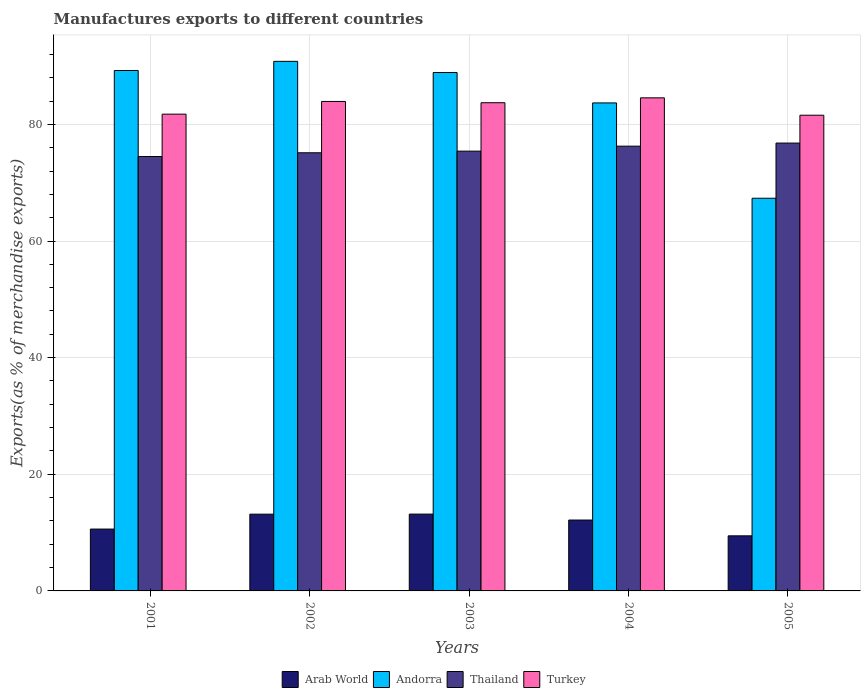How many groups of bars are there?
Keep it short and to the point. 5. Are the number of bars per tick equal to the number of legend labels?
Your answer should be compact. Yes. Are the number of bars on each tick of the X-axis equal?
Make the answer very short. Yes. How many bars are there on the 2nd tick from the left?
Your response must be concise. 4. What is the percentage of exports to different countries in Turkey in 2002?
Make the answer very short. 83.93. Across all years, what is the maximum percentage of exports to different countries in Turkey?
Offer a very short reply. 84.55. Across all years, what is the minimum percentage of exports to different countries in Turkey?
Your answer should be compact. 81.57. What is the total percentage of exports to different countries in Turkey in the graph?
Give a very brief answer. 415.52. What is the difference between the percentage of exports to different countries in Thailand in 2003 and that in 2005?
Give a very brief answer. -1.38. What is the difference between the percentage of exports to different countries in Thailand in 2003 and the percentage of exports to different countries in Andorra in 2001?
Make the answer very short. -13.83. What is the average percentage of exports to different countries in Andorra per year?
Give a very brief answer. 83.99. In the year 2005, what is the difference between the percentage of exports to different countries in Turkey and percentage of exports to different countries in Arab World?
Offer a terse response. 72.13. In how many years, is the percentage of exports to different countries in Andorra greater than 20 %?
Your answer should be compact. 5. What is the ratio of the percentage of exports to different countries in Turkey in 2001 to that in 2003?
Offer a terse response. 0.98. Is the percentage of exports to different countries in Turkey in 2004 less than that in 2005?
Provide a short and direct response. No. What is the difference between the highest and the second highest percentage of exports to different countries in Arab World?
Ensure brevity in your answer.  0.01. What is the difference between the highest and the lowest percentage of exports to different countries in Turkey?
Provide a succinct answer. 2.98. In how many years, is the percentage of exports to different countries in Thailand greater than the average percentage of exports to different countries in Thailand taken over all years?
Your answer should be very brief. 2. What does the 3rd bar from the left in 2005 represents?
Offer a terse response. Thailand. What does the 1st bar from the right in 2005 represents?
Your response must be concise. Turkey. Is it the case that in every year, the sum of the percentage of exports to different countries in Arab World and percentage of exports to different countries in Turkey is greater than the percentage of exports to different countries in Andorra?
Your answer should be very brief. Yes. How many bars are there?
Make the answer very short. 20. Are all the bars in the graph horizontal?
Make the answer very short. No. What is the difference between two consecutive major ticks on the Y-axis?
Offer a very short reply. 20. Does the graph contain grids?
Your answer should be very brief. Yes. How are the legend labels stacked?
Provide a short and direct response. Horizontal. What is the title of the graph?
Make the answer very short. Manufactures exports to different countries. Does "Heavily indebted poor countries" appear as one of the legend labels in the graph?
Provide a short and direct response. No. What is the label or title of the Y-axis?
Make the answer very short. Exports(as % of merchandise exports). What is the Exports(as % of merchandise exports) in Arab World in 2001?
Your response must be concise. 10.61. What is the Exports(as % of merchandise exports) in Andorra in 2001?
Offer a very short reply. 89.24. What is the Exports(as % of merchandise exports) in Thailand in 2001?
Your answer should be compact. 74.49. What is the Exports(as % of merchandise exports) in Turkey in 2001?
Provide a short and direct response. 81.75. What is the Exports(as % of merchandise exports) of Arab World in 2002?
Offer a very short reply. 13.16. What is the Exports(as % of merchandise exports) in Andorra in 2002?
Your answer should be compact. 90.81. What is the Exports(as % of merchandise exports) of Thailand in 2002?
Provide a short and direct response. 75.13. What is the Exports(as % of merchandise exports) in Turkey in 2002?
Give a very brief answer. 83.93. What is the Exports(as % of merchandise exports) in Arab World in 2003?
Give a very brief answer. 13.17. What is the Exports(as % of merchandise exports) of Andorra in 2003?
Give a very brief answer. 88.89. What is the Exports(as % of merchandise exports) of Thailand in 2003?
Keep it short and to the point. 75.41. What is the Exports(as % of merchandise exports) in Turkey in 2003?
Offer a very short reply. 83.71. What is the Exports(as % of merchandise exports) of Arab World in 2004?
Offer a very short reply. 12.15. What is the Exports(as % of merchandise exports) of Andorra in 2004?
Provide a short and direct response. 83.68. What is the Exports(as % of merchandise exports) of Thailand in 2004?
Your answer should be very brief. 76.26. What is the Exports(as % of merchandise exports) of Turkey in 2004?
Offer a very short reply. 84.55. What is the Exports(as % of merchandise exports) in Arab World in 2005?
Ensure brevity in your answer.  9.45. What is the Exports(as % of merchandise exports) in Andorra in 2005?
Keep it short and to the point. 67.34. What is the Exports(as % of merchandise exports) of Thailand in 2005?
Offer a very short reply. 76.8. What is the Exports(as % of merchandise exports) of Turkey in 2005?
Provide a short and direct response. 81.57. Across all years, what is the maximum Exports(as % of merchandise exports) of Arab World?
Give a very brief answer. 13.17. Across all years, what is the maximum Exports(as % of merchandise exports) in Andorra?
Your answer should be compact. 90.81. Across all years, what is the maximum Exports(as % of merchandise exports) in Thailand?
Offer a terse response. 76.8. Across all years, what is the maximum Exports(as % of merchandise exports) in Turkey?
Offer a very short reply. 84.55. Across all years, what is the minimum Exports(as % of merchandise exports) of Arab World?
Your answer should be compact. 9.45. Across all years, what is the minimum Exports(as % of merchandise exports) of Andorra?
Offer a terse response. 67.34. Across all years, what is the minimum Exports(as % of merchandise exports) of Thailand?
Offer a very short reply. 74.49. Across all years, what is the minimum Exports(as % of merchandise exports) of Turkey?
Keep it short and to the point. 81.57. What is the total Exports(as % of merchandise exports) in Arab World in the graph?
Your answer should be compact. 58.54. What is the total Exports(as % of merchandise exports) of Andorra in the graph?
Make the answer very short. 419.95. What is the total Exports(as % of merchandise exports) of Thailand in the graph?
Your answer should be very brief. 378.09. What is the total Exports(as % of merchandise exports) in Turkey in the graph?
Make the answer very short. 415.52. What is the difference between the Exports(as % of merchandise exports) of Arab World in 2001 and that in 2002?
Give a very brief answer. -2.56. What is the difference between the Exports(as % of merchandise exports) of Andorra in 2001 and that in 2002?
Make the answer very short. -1.57. What is the difference between the Exports(as % of merchandise exports) in Thailand in 2001 and that in 2002?
Ensure brevity in your answer.  -0.64. What is the difference between the Exports(as % of merchandise exports) in Turkey in 2001 and that in 2002?
Ensure brevity in your answer.  -2.18. What is the difference between the Exports(as % of merchandise exports) of Arab World in 2001 and that in 2003?
Offer a very short reply. -2.56. What is the difference between the Exports(as % of merchandise exports) of Andorra in 2001 and that in 2003?
Ensure brevity in your answer.  0.35. What is the difference between the Exports(as % of merchandise exports) in Thailand in 2001 and that in 2003?
Ensure brevity in your answer.  -0.92. What is the difference between the Exports(as % of merchandise exports) in Turkey in 2001 and that in 2003?
Ensure brevity in your answer.  -1.96. What is the difference between the Exports(as % of merchandise exports) of Arab World in 2001 and that in 2004?
Provide a short and direct response. -1.55. What is the difference between the Exports(as % of merchandise exports) in Andorra in 2001 and that in 2004?
Your answer should be very brief. 5.56. What is the difference between the Exports(as % of merchandise exports) in Thailand in 2001 and that in 2004?
Your response must be concise. -1.78. What is the difference between the Exports(as % of merchandise exports) of Turkey in 2001 and that in 2004?
Ensure brevity in your answer.  -2.8. What is the difference between the Exports(as % of merchandise exports) of Arab World in 2001 and that in 2005?
Ensure brevity in your answer.  1.16. What is the difference between the Exports(as % of merchandise exports) of Andorra in 2001 and that in 2005?
Ensure brevity in your answer.  21.9. What is the difference between the Exports(as % of merchandise exports) of Thailand in 2001 and that in 2005?
Ensure brevity in your answer.  -2.31. What is the difference between the Exports(as % of merchandise exports) in Turkey in 2001 and that in 2005?
Provide a short and direct response. 0.18. What is the difference between the Exports(as % of merchandise exports) of Arab World in 2002 and that in 2003?
Provide a short and direct response. -0.01. What is the difference between the Exports(as % of merchandise exports) of Andorra in 2002 and that in 2003?
Give a very brief answer. 1.91. What is the difference between the Exports(as % of merchandise exports) of Thailand in 2002 and that in 2003?
Offer a terse response. -0.28. What is the difference between the Exports(as % of merchandise exports) in Turkey in 2002 and that in 2003?
Provide a succinct answer. 0.22. What is the difference between the Exports(as % of merchandise exports) of Andorra in 2002 and that in 2004?
Ensure brevity in your answer.  7.13. What is the difference between the Exports(as % of merchandise exports) of Thailand in 2002 and that in 2004?
Make the answer very short. -1.13. What is the difference between the Exports(as % of merchandise exports) of Turkey in 2002 and that in 2004?
Offer a terse response. -0.62. What is the difference between the Exports(as % of merchandise exports) of Arab World in 2002 and that in 2005?
Your answer should be very brief. 3.72. What is the difference between the Exports(as % of merchandise exports) in Andorra in 2002 and that in 2005?
Keep it short and to the point. 23.47. What is the difference between the Exports(as % of merchandise exports) in Thailand in 2002 and that in 2005?
Offer a very short reply. -1.67. What is the difference between the Exports(as % of merchandise exports) in Turkey in 2002 and that in 2005?
Your response must be concise. 2.36. What is the difference between the Exports(as % of merchandise exports) of Arab World in 2003 and that in 2004?
Provide a succinct answer. 1.02. What is the difference between the Exports(as % of merchandise exports) of Andorra in 2003 and that in 2004?
Your answer should be very brief. 5.21. What is the difference between the Exports(as % of merchandise exports) in Thailand in 2003 and that in 2004?
Your answer should be very brief. -0.85. What is the difference between the Exports(as % of merchandise exports) in Turkey in 2003 and that in 2004?
Offer a terse response. -0.84. What is the difference between the Exports(as % of merchandise exports) in Arab World in 2003 and that in 2005?
Provide a succinct answer. 3.72. What is the difference between the Exports(as % of merchandise exports) in Andorra in 2003 and that in 2005?
Your answer should be very brief. 21.56. What is the difference between the Exports(as % of merchandise exports) of Thailand in 2003 and that in 2005?
Make the answer very short. -1.38. What is the difference between the Exports(as % of merchandise exports) of Turkey in 2003 and that in 2005?
Make the answer very short. 2.14. What is the difference between the Exports(as % of merchandise exports) of Arab World in 2004 and that in 2005?
Give a very brief answer. 2.71. What is the difference between the Exports(as % of merchandise exports) in Andorra in 2004 and that in 2005?
Your response must be concise. 16.34. What is the difference between the Exports(as % of merchandise exports) of Thailand in 2004 and that in 2005?
Offer a very short reply. -0.53. What is the difference between the Exports(as % of merchandise exports) in Turkey in 2004 and that in 2005?
Your response must be concise. 2.98. What is the difference between the Exports(as % of merchandise exports) of Arab World in 2001 and the Exports(as % of merchandise exports) of Andorra in 2002?
Your response must be concise. -80.2. What is the difference between the Exports(as % of merchandise exports) in Arab World in 2001 and the Exports(as % of merchandise exports) in Thailand in 2002?
Offer a terse response. -64.52. What is the difference between the Exports(as % of merchandise exports) in Arab World in 2001 and the Exports(as % of merchandise exports) in Turkey in 2002?
Provide a succinct answer. -73.33. What is the difference between the Exports(as % of merchandise exports) in Andorra in 2001 and the Exports(as % of merchandise exports) in Thailand in 2002?
Your answer should be very brief. 14.11. What is the difference between the Exports(as % of merchandise exports) of Andorra in 2001 and the Exports(as % of merchandise exports) of Turkey in 2002?
Offer a very short reply. 5.31. What is the difference between the Exports(as % of merchandise exports) of Thailand in 2001 and the Exports(as % of merchandise exports) of Turkey in 2002?
Give a very brief answer. -9.45. What is the difference between the Exports(as % of merchandise exports) of Arab World in 2001 and the Exports(as % of merchandise exports) of Andorra in 2003?
Ensure brevity in your answer.  -78.29. What is the difference between the Exports(as % of merchandise exports) of Arab World in 2001 and the Exports(as % of merchandise exports) of Thailand in 2003?
Offer a terse response. -64.8. What is the difference between the Exports(as % of merchandise exports) in Arab World in 2001 and the Exports(as % of merchandise exports) in Turkey in 2003?
Keep it short and to the point. -73.11. What is the difference between the Exports(as % of merchandise exports) of Andorra in 2001 and the Exports(as % of merchandise exports) of Thailand in 2003?
Keep it short and to the point. 13.83. What is the difference between the Exports(as % of merchandise exports) in Andorra in 2001 and the Exports(as % of merchandise exports) in Turkey in 2003?
Your answer should be compact. 5.53. What is the difference between the Exports(as % of merchandise exports) in Thailand in 2001 and the Exports(as % of merchandise exports) in Turkey in 2003?
Make the answer very short. -9.23. What is the difference between the Exports(as % of merchandise exports) in Arab World in 2001 and the Exports(as % of merchandise exports) in Andorra in 2004?
Offer a terse response. -73.07. What is the difference between the Exports(as % of merchandise exports) of Arab World in 2001 and the Exports(as % of merchandise exports) of Thailand in 2004?
Ensure brevity in your answer.  -65.66. What is the difference between the Exports(as % of merchandise exports) in Arab World in 2001 and the Exports(as % of merchandise exports) in Turkey in 2004?
Provide a succinct answer. -73.94. What is the difference between the Exports(as % of merchandise exports) in Andorra in 2001 and the Exports(as % of merchandise exports) in Thailand in 2004?
Offer a terse response. 12.98. What is the difference between the Exports(as % of merchandise exports) in Andorra in 2001 and the Exports(as % of merchandise exports) in Turkey in 2004?
Keep it short and to the point. 4.69. What is the difference between the Exports(as % of merchandise exports) in Thailand in 2001 and the Exports(as % of merchandise exports) in Turkey in 2004?
Ensure brevity in your answer.  -10.06. What is the difference between the Exports(as % of merchandise exports) of Arab World in 2001 and the Exports(as % of merchandise exports) of Andorra in 2005?
Keep it short and to the point. -56.73. What is the difference between the Exports(as % of merchandise exports) of Arab World in 2001 and the Exports(as % of merchandise exports) of Thailand in 2005?
Offer a terse response. -66.19. What is the difference between the Exports(as % of merchandise exports) of Arab World in 2001 and the Exports(as % of merchandise exports) of Turkey in 2005?
Ensure brevity in your answer.  -70.97. What is the difference between the Exports(as % of merchandise exports) in Andorra in 2001 and the Exports(as % of merchandise exports) in Thailand in 2005?
Offer a terse response. 12.44. What is the difference between the Exports(as % of merchandise exports) in Andorra in 2001 and the Exports(as % of merchandise exports) in Turkey in 2005?
Ensure brevity in your answer.  7.67. What is the difference between the Exports(as % of merchandise exports) in Thailand in 2001 and the Exports(as % of merchandise exports) in Turkey in 2005?
Offer a terse response. -7.09. What is the difference between the Exports(as % of merchandise exports) of Arab World in 2002 and the Exports(as % of merchandise exports) of Andorra in 2003?
Provide a succinct answer. -75.73. What is the difference between the Exports(as % of merchandise exports) of Arab World in 2002 and the Exports(as % of merchandise exports) of Thailand in 2003?
Provide a succinct answer. -62.25. What is the difference between the Exports(as % of merchandise exports) of Arab World in 2002 and the Exports(as % of merchandise exports) of Turkey in 2003?
Your response must be concise. -70.55. What is the difference between the Exports(as % of merchandise exports) in Andorra in 2002 and the Exports(as % of merchandise exports) in Thailand in 2003?
Offer a very short reply. 15.4. What is the difference between the Exports(as % of merchandise exports) of Andorra in 2002 and the Exports(as % of merchandise exports) of Turkey in 2003?
Your answer should be compact. 7.09. What is the difference between the Exports(as % of merchandise exports) in Thailand in 2002 and the Exports(as % of merchandise exports) in Turkey in 2003?
Provide a short and direct response. -8.58. What is the difference between the Exports(as % of merchandise exports) in Arab World in 2002 and the Exports(as % of merchandise exports) in Andorra in 2004?
Your answer should be compact. -70.52. What is the difference between the Exports(as % of merchandise exports) of Arab World in 2002 and the Exports(as % of merchandise exports) of Thailand in 2004?
Keep it short and to the point. -63.1. What is the difference between the Exports(as % of merchandise exports) of Arab World in 2002 and the Exports(as % of merchandise exports) of Turkey in 2004?
Offer a very short reply. -71.39. What is the difference between the Exports(as % of merchandise exports) of Andorra in 2002 and the Exports(as % of merchandise exports) of Thailand in 2004?
Your answer should be very brief. 14.54. What is the difference between the Exports(as % of merchandise exports) in Andorra in 2002 and the Exports(as % of merchandise exports) in Turkey in 2004?
Offer a terse response. 6.26. What is the difference between the Exports(as % of merchandise exports) in Thailand in 2002 and the Exports(as % of merchandise exports) in Turkey in 2004?
Give a very brief answer. -9.42. What is the difference between the Exports(as % of merchandise exports) of Arab World in 2002 and the Exports(as % of merchandise exports) of Andorra in 2005?
Ensure brevity in your answer.  -54.17. What is the difference between the Exports(as % of merchandise exports) in Arab World in 2002 and the Exports(as % of merchandise exports) in Thailand in 2005?
Your answer should be very brief. -63.63. What is the difference between the Exports(as % of merchandise exports) in Arab World in 2002 and the Exports(as % of merchandise exports) in Turkey in 2005?
Make the answer very short. -68.41. What is the difference between the Exports(as % of merchandise exports) in Andorra in 2002 and the Exports(as % of merchandise exports) in Thailand in 2005?
Ensure brevity in your answer.  14.01. What is the difference between the Exports(as % of merchandise exports) in Andorra in 2002 and the Exports(as % of merchandise exports) in Turkey in 2005?
Provide a succinct answer. 9.23. What is the difference between the Exports(as % of merchandise exports) of Thailand in 2002 and the Exports(as % of merchandise exports) of Turkey in 2005?
Your answer should be very brief. -6.44. What is the difference between the Exports(as % of merchandise exports) of Arab World in 2003 and the Exports(as % of merchandise exports) of Andorra in 2004?
Give a very brief answer. -70.51. What is the difference between the Exports(as % of merchandise exports) of Arab World in 2003 and the Exports(as % of merchandise exports) of Thailand in 2004?
Keep it short and to the point. -63.09. What is the difference between the Exports(as % of merchandise exports) in Arab World in 2003 and the Exports(as % of merchandise exports) in Turkey in 2004?
Your response must be concise. -71.38. What is the difference between the Exports(as % of merchandise exports) of Andorra in 2003 and the Exports(as % of merchandise exports) of Thailand in 2004?
Provide a short and direct response. 12.63. What is the difference between the Exports(as % of merchandise exports) in Andorra in 2003 and the Exports(as % of merchandise exports) in Turkey in 2004?
Make the answer very short. 4.34. What is the difference between the Exports(as % of merchandise exports) in Thailand in 2003 and the Exports(as % of merchandise exports) in Turkey in 2004?
Keep it short and to the point. -9.14. What is the difference between the Exports(as % of merchandise exports) of Arab World in 2003 and the Exports(as % of merchandise exports) of Andorra in 2005?
Your answer should be very brief. -54.16. What is the difference between the Exports(as % of merchandise exports) of Arab World in 2003 and the Exports(as % of merchandise exports) of Thailand in 2005?
Offer a terse response. -63.62. What is the difference between the Exports(as % of merchandise exports) of Arab World in 2003 and the Exports(as % of merchandise exports) of Turkey in 2005?
Make the answer very short. -68.4. What is the difference between the Exports(as % of merchandise exports) in Andorra in 2003 and the Exports(as % of merchandise exports) in Thailand in 2005?
Your answer should be very brief. 12.1. What is the difference between the Exports(as % of merchandise exports) in Andorra in 2003 and the Exports(as % of merchandise exports) in Turkey in 2005?
Ensure brevity in your answer.  7.32. What is the difference between the Exports(as % of merchandise exports) in Thailand in 2003 and the Exports(as % of merchandise exports) in Turkey in 2005?
Your answer should be compact. -6.16. What is the difference between the Exports(as % of merchandise exports) of Arab World in 2004 and the Exports(as % of merchandise exports) of Andorra in 2005?
Your answer should be compact. -55.18. What is the difference between the Exports(as % of merchandise exports) of Arab World in 2004 and the Exports(as % of merchandise exports) of Thailand in 2005?
Ensure brevity in your answer.  -64.64. What is the difference between the Exports(as % of merchandise exports) in Arab World in 2004 and the Exports(as % of merchandise exports) in Turkey in 2005?
Offer a terse response. -69.42. What is the difference between the Exports(as % of merchandise exports) in Andorra in 2004 and the Exports(as % of merchandise exports) in Thailand in 2005?
Make the answer very short. 6.88. What is the difference between the Exports(as % of merchandise exports) in Andorra in 2004 and the Exports(as % of merchandise exports) in Turkey in 2005?
Your answer should be very brief. 2.11. What is the difference between the Exports(as % of merchandise exports) in Thailand in 2004 and the Exports(as % of merchandise exports) in Turkey in 2005?
Give a very brief answer. -5.31. What is the average Exports(as % of merchandise exports) in Arab World per year?
Make the answer very short. 11.71. What is the average Exports(as % of merchandise exports) of Andorra per year?
Your answer should be compact. 83.99. What is the average Exports(as % of merchandise exports) of Thailand per year?
Keep it short and to the point. 75.62. What is the average Exports(as % of merchandise exports) of Turkey per year?
Your response must be concise. 83.1. In the year 2001, what is the difference between the Exports(as % of merchandise exports) of Arab World and Exports(as % of merchandise exports) of Andorra?
Your answer should be compact. -78.63. In the year 2001, what is the difference between the Exports(as % of merchandise exports) in Arab World and Exports(as % of merchandise exports) in Thailand?
Give a very brief answer. -63.88. In the year 2001, what is the difference between the Exports(as % of merchandise exports) in Arab World and Exports(as % of merchandise exports) in Turkey?
Your answer should be compact. -71.15. In the year 2001, what is the difference between the Exports(as % of merchandise exports) in Andorra and Exports(as % of merchandise exports) in Thailand?
Provide a succinct answer. 14.75. In the year 2001, what is the difference between the Exports(as % of merchandise exports) of Andorra and Exports(as % of merchandise exports) of Turkey?
Provide a succinct answer. 7.49. In the year 2001, what is the difference between the Exports(as % of merchandise exports) of Thailand and Exports(as % of merchandise exports) of Turkey?
Keep it short and to the point. -7.27. In the year 2002, what is the difference between the Exports(as % of merchandise exports) in Arab World and Exports(as % of merchandise exports) in Andorra?
Make the answer very short. -77.64. In the year 2002, what is the difference between the Exports(as % of merchandise exports) in Arab World and Exports(as % of merchandise exports) in Thailand?
Keep it short and to the point. -61.97. In the year 2002, what is the difference between the Exports(as % of merchandise exports) in Arab World and Exports(as % of merchandise exports) in Turkey?
Provide a short and direct response. -70.77. In the year 2002, what is the difference between the Exports(as % of merchandise exports) of Andorra and Exports(as % of merchandise exports) of Thailand?
Give a very brief answer. 15.68. In the year 2002, what is the difference between the Exports(as % of merchandise exports) of Andorra and Exports(as % of merchandise exports) of Turkey?
Offer a terse response. 6.87. In the year 2002, what is the difference between the Exports(as % of merchandise exports) in Thailand and Exports(as % of merchandise exports) in Turkey?
Provide a short and direct response. -8.8. In the year 2003, what is the difference between the Exports(as % of merchandise exports) of Arab World and Exports(as % of merchandise exports) of Andorra?
Ensure brevity in your answer.  -75.72. In the year 2003, what is the difference between the Exports(as % of merchandise exports) in Arab World and Exports(as % of merchandise exports) in Thailand?
Give a very brief answer. -62.24. In the year 2003, what is the difference between the Exports(as % of merchandise exports) of Arab World and Exports(as % of merchandise exports) of Turkey?
Keep it short and to the point. -70.54. In the year 2003, what is the difference between the Exports(as % of merchandise exports) in Andorra and Exports(as % of merchandise exports) in Thailand?
Give a very brief answer. 13.48. In the year 2003, what is the difference between the Exports(as % of merchandise exports) in Andorra and Exports(as % of merchandise exports) in Turkey?
Your response must be concise. 5.18. In the year 2003, what is the difference between the Exports(as % of merchandise exports) in Thailand and Exports(as % of merchandise exports) in Turkey?
Offer a terse response. -8.3. In the year 2004, what is the difference between the Exports(as % of merchandise exports) in Arab World and Exports(as % of merchandise exports) in Andorra?
Provide a short and direct response. -71.53. In the year 2004, what is the difference between the Exports(as % of merchandise exports) in Arab World and Exports(as % of merchandise exports) in Thailand?
Provide a short and direct response. -64.11. In the year 2004, what is the difference between the Exports(as % of merchandise exports) of Arab World and Exports(as % of merchandise exports) of Turkey?
Provide a short and direct response. -72.4. In the year 2004, what is the difference between the Exports(as % of merchandise exports) of Andorra and Exports(as % of merchandise exports) of Thailand?
Provide a short and direct response. 7.42. In the year 2004, what is the difference between the Exports(as % of merchandise exports) in Andorra and Exports(as % of merchandise exports) in Turkey?
Your answer should be very brief. -0.87. In the year 2004, what is the difference between the Exports(as % of merchandise exports) in Thailand and Exports(as % of merchandise exports) in Turkey?
Your answer should be very brief. -8.29. In the year 2005, what is the difference between the Exports(as % of merchandise exports) of Arab World and Exports(as % of merchandise exports) of Andorra?
Make the answer very short. -57.89. In the year 2005, what is the difference between the Exports(as % of merchandise exports) of Arab World and Exports(as % of merchandise exports) of Thailand?
Keep it short and to the point. -67.35. In the year 2005, what is the difference between the Exports(as % of merchandise exports) of Arab World and Exports(as % of merchandise exports) of Turkey?
Your answer should be very brief. -72.13. In the year 2005, what is the difference between the Exports(as % of merchandise exports) in Andorra and Exports(as % of merchandise exports) in Thailand?
Keep it short and to the point. -9.46. In the year 2005, what is the difference between the Exports(as % of merchandise exports) in Andorra and Exports(as % of merchandise exports) in Turkey?
Your response must be concise. -14.24. In the year 2005, what is the difference between the Exports(as % of merchandise exports) in Thailand and Exports(as % of merchandise exports) in Turkey?
Offer a very short reply. -4.78. What is the ratio of the Exports(as % of merchandise exports) in Arab World in 2001 to that in 2002?
Provide a short and direct response. 0.81. What is the ratio of the Exports(as % of merchandise exports) in Andorra in 2001 to that in 2002?
Offer a terse response. 0.98. What is the ratio of the Exports(as % of merchandise exports) of Turkey in 2001 to that in 2002?
Your response must be concise. 0.97. What is the ratio of the Exports(as % of merchandise exports) in Arab World in 2001 to that in 2003?
Provide a short and direct response. 0.81. What is the ratio of the Exports(as % of merchandise exports) in Andorra in 2001 to that in 2003?
Your answer should be compact. 1. What is the ratio of the Exports(as % of merchandise exports) in Turkey in 2001 to that in 2003?
Give a very brief answer. 0.98. What is the ratio of the Exports(as % of merchandise exports) of Arab World in 2001 to that in 2004?
Ensure brevity in your answer.  0.87. What is the ratio of the Exports(as % of merchandise exports) in Andorra in 2001 to that in 2004?
Your answer should be compact. 1.07. What is the ratio of the Exports(as % of merchandise exports) of Thailand in 2001 to that in 2004?
Provide a succinct answer. 0.98. What is the ratio of the Exports(as % of merchandise exports) of Turkey in 2001 to that in 2004?
Keep it short and to the point. 0.97. What is the ratio of the Exports(as % of merchandise exports) in Arab World in 2001 to that in 2005?
Keep it short and to the point. 1.12. What is the ratio of the Exports(as % of merchandise exports) of Andorra in 2001 to that in 2005?
Keep it short and to the point. 1.33. What is the ratio of the Exports(as % of merchandise exports) in Thailand in 2001 to that in 2005?
Provide a short and direct response. 0.97. What is the ratio of the Exports(as % of merchandise exports) in Turkey in 2001 to that in 2005?
Your answer should be very brief. 1. What is the ratio of the Exports(as % of merchandise exports) in Andorra in 2002 to that in 2003?
Your answer should be compact. 1.02. What is the ratio of the Exports(as % of merchandise exports) in Turkey in 2002 to that in 2003?
Make the answer very short. 1. What is the ratio of the Exports(as % of merchandise exports) in Arab World in 2002 to that in 2004?
Make the answer very short. 1.08. What is the ratio of the Exports(as % of merchandise exports) of Andorra in 2002 to that in 2004?
Your response must be concise. 1.09. What is the ratio of the Exports(as % of merchandise exports) in Thailand in 2002 to that in 2004?
Give a very brief answer. 0.99. What is the ratio of the Exports(as % of merchandise exports) in Turkey in 2002 to that in 2004?
Give a very brief answer. 0.99. What is the ratio of the Exports(as % of merchandise exports) of Arab World in 2002 to that in 2005?
Provide a succinct answer. 1.39. What is the ratio of the Exports(as % of merchandise exports) in Andorra in 2002 to that in 2005?
Your answer should be very brief. 1.35. What is the ratio of the Exports(as % of merchandise exports) of Thailand in 2002 to that in 2005?
Ensure brevity in your answer.  0.98. What is the ratio of the Exports(as % of merchandise exports) of Turkey in 2002 to that in 2005?
Give a very brief answer. 1.03. What is the ratio of the Exports(as % of merchandise exports) of Arab World in 2003 to that in 2004?
Make the answer very short. 1.08. What is the ratio of the Exports(as % of merchandise exports) of Andorra in 2003 to that in 2004?
Make the answer very short. 1.06. What is the ratio of the Exports(as % of merchandise exports) in Thailand in 2003 to that in 2004?
Your response must be concise. 0.99. What is the ratio of the Exports(as % of merchandise exports) of Arab World in 2003 to that in 2005?
Offer a very short reply. 1.39. What is the ratio of the Exports(as % of merchandise exports) in Andorra in 2003 to that in 2005?
Give a very brief answer. 1.32. What is the ratio of the Exports(as % of merchandise exports) of Thailand in 2003 to that in 2005?
Your answer should be compact. 0.98. What is the ratio of the Exports(as % of merchandise exports) in Turkey in 2003 to that in 2005?
Make the answer very short. 1.03. What is the ratio of the Exports(as % of merchandise exports) in Arab World in 2004 to that in 2005?
Give a very brief answer. 1.29. What is the ratio of the Exports(as % of merchandise exports) in Andorra in 2004 to that in 2005?
Provide a succinct answer. 1.24. What is the ratio of the Exports(as % of merchandise exports) of Turkey in 2004 to that in 2005?
Give a very brief answer. 1.04. What is the difference between the highest and the second highest Exports(as % of merchandise exports) in Arab World?
Offer a very short reply. 0.01. What is the difference between the highest and the second highest Exports(as % of merchandise exports) in Andorra?
Your answer should be compact. 1.57. What is the difference between the highest and the second highest Exports(as % of merchandise exports) of Thailand?
Give a very brief answer. 0.53. What is the difference between the highest and the second highest Exports(as % of merchandise exports) of Turkey?
Your response must be concise. 0.62. What is the difference between the highest and the lowest Exports(as % of merchandise exports) in Arab World?
Give a very brief answer. 3.72. What is the difference between the highest and the lowest Exports(as % of merchandise exports) of Andorra?
Provide a short and direct response. 23.47. What is the difference between the highest and the lowest Exports(as % of merchandise exports) of Thailand?
Your response must be concise. 2.31. What is the difference between the highest and the lowest Exports(as % of merchandise exports) in Turkey?
Provide a succinct answer. 2.98. 